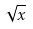<formula> <loc_0><loc_0><loc_500><loc_500>\sqrt { x }</formula> 